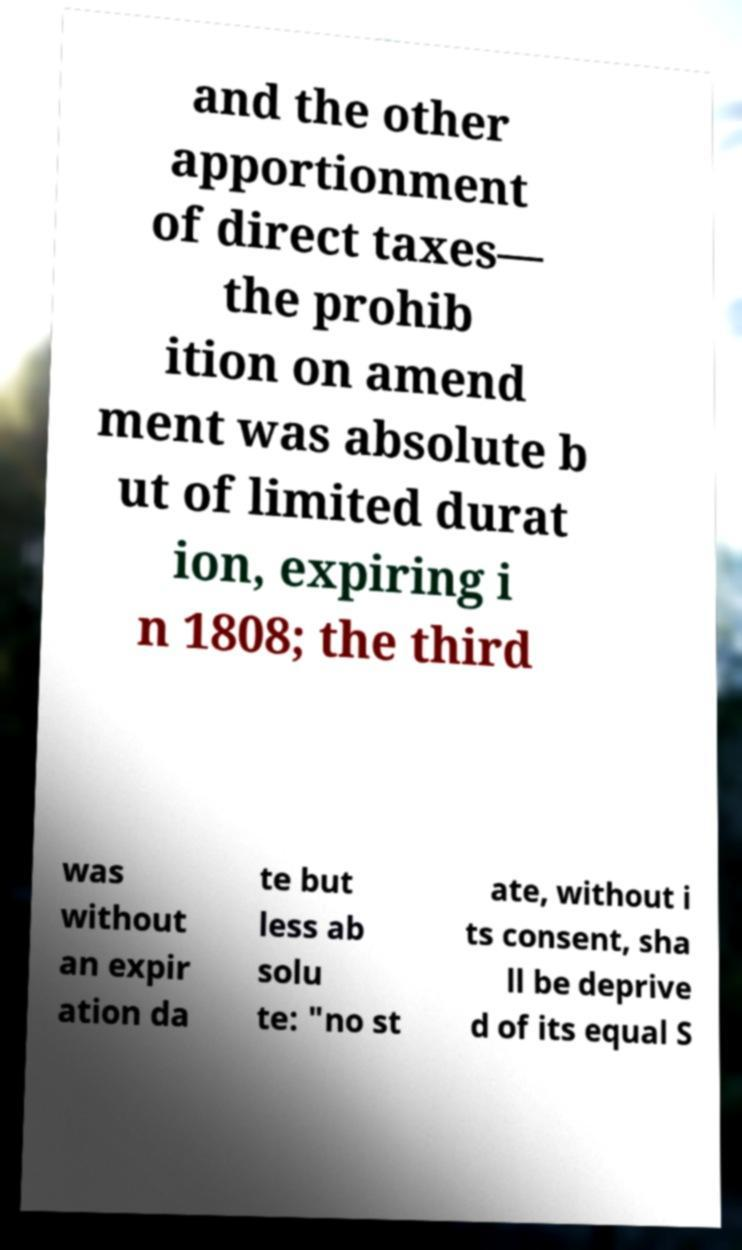Can you read and provide the text displayed in the image?This photo seems to have some interesting text. Can you extract and type it out for me? and the other apportionment of direct taxes— the prohib ition on amend ment was absolute b ut of limited durat ion, expiring i n 1808; the third was without an expir ation da te but less ab solu te: "no st ate, without i ts consent, sha ll be deprive d of its equal S 